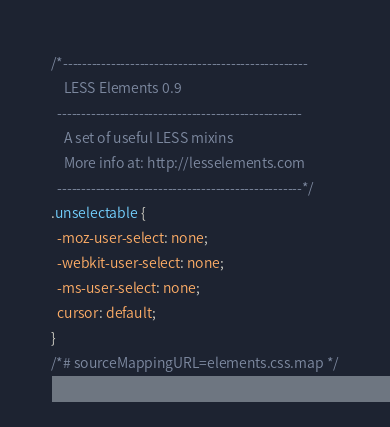Convert code to text. <code><loc_0><loc_0><loc_500><loc_500><_CSS_>/*---------------------------------------------------
    LESS Elements 0.9
  ---------------------------------------------------
    A set of useful LESS mixins
    More info at: http://lesselements.com
  ---------------------------------------------------*/
.unselectable {
  -moz-user-select: none;
  -webkit-user-select: none;
  -ms-user-select: none;
  cursor: default;
}
/*# sourceMappingURL=elements.css.map */</code> 